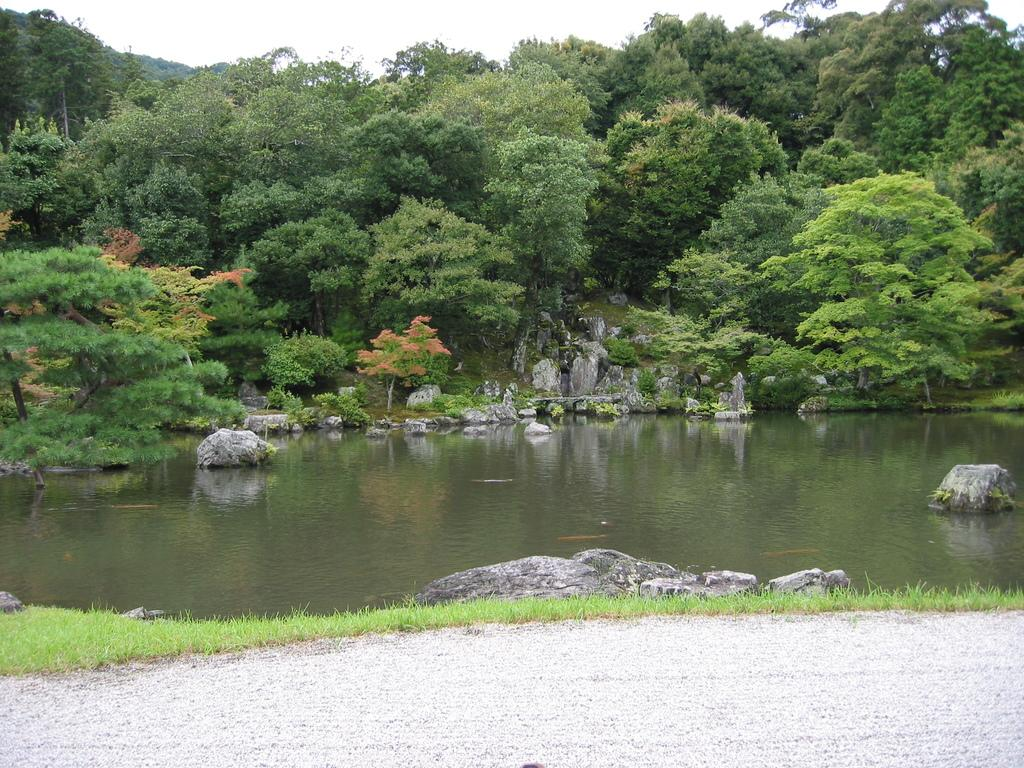What is one of the natural elements present in the image? There is water in the image. What type of vegetation can be seen in the image? There is grass, plants, and trees in the image. What is the ground like in the image? The ground is visible in the image, and there are rocks present. What can be seen in the background of the image? The sky is visible in the background of the image. How many boats are visible in the image? There are no boats present in the image. Can you tell me the credit score of the person in the image? There is no person in the image, and therefore no credit score can be determined. 